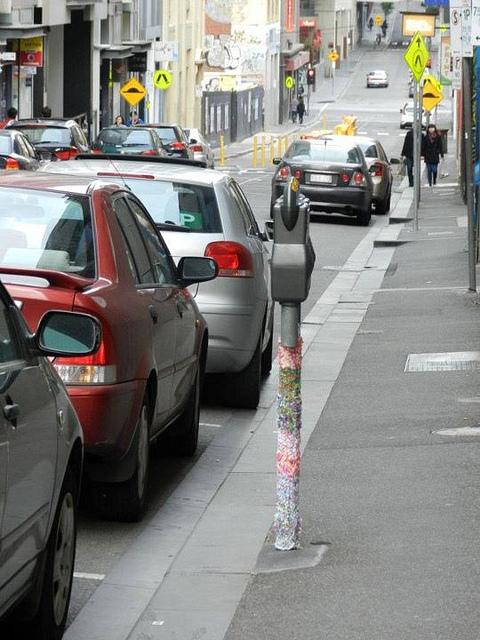Is the parking meter post decorated?
Give a very brief answer. Yes. Is there a sidewalk?
Keep it brief. Yes. What color are the signs?
Answer briefly. Yellow. 